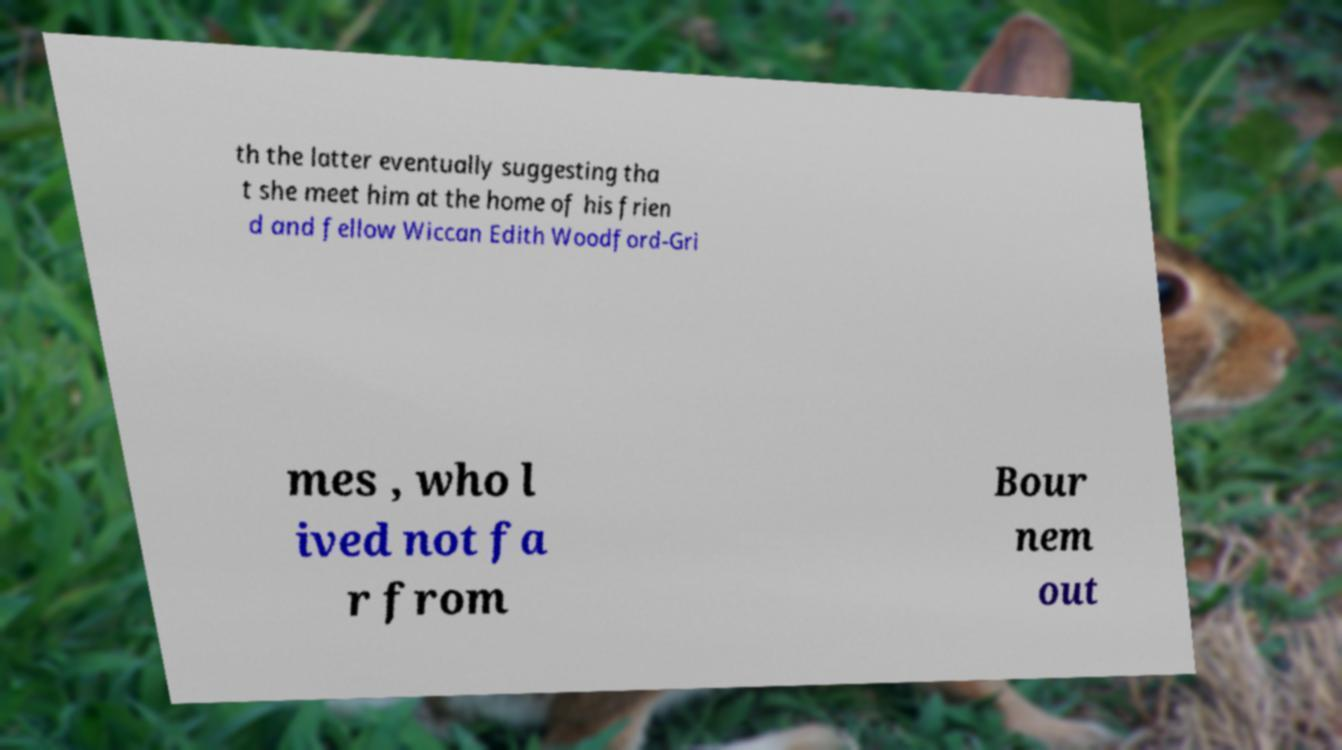Please identify and transcribe the text found in this image. th the latter eventually suggesting tha t she meet him at the home of his frien d and fellow Wiccan Edith Woodford-Gri mes , who l ived not fa r from Bour nem out 